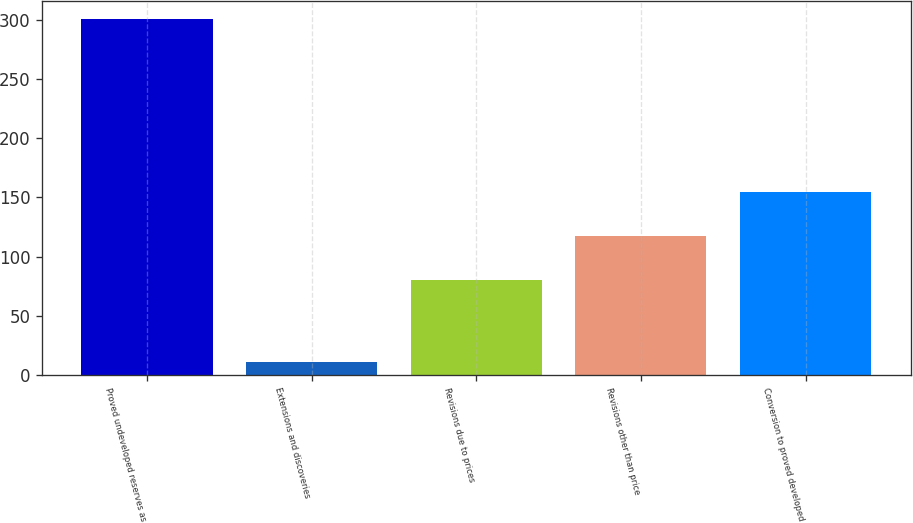<chart> <loc_0><loc_0><loc_500><loc_500><bar_chart><fcel>Proved undeveloped reserves as<fcel>Extensions and discoveries<fcel>Revisions due to prices<fcel>Revisions other than price<fcel>Conversion to proved developed<nl><fcel>301<fcel>11<fcel>80<fcel>117.3<fcel>154.6<nl></chart> 